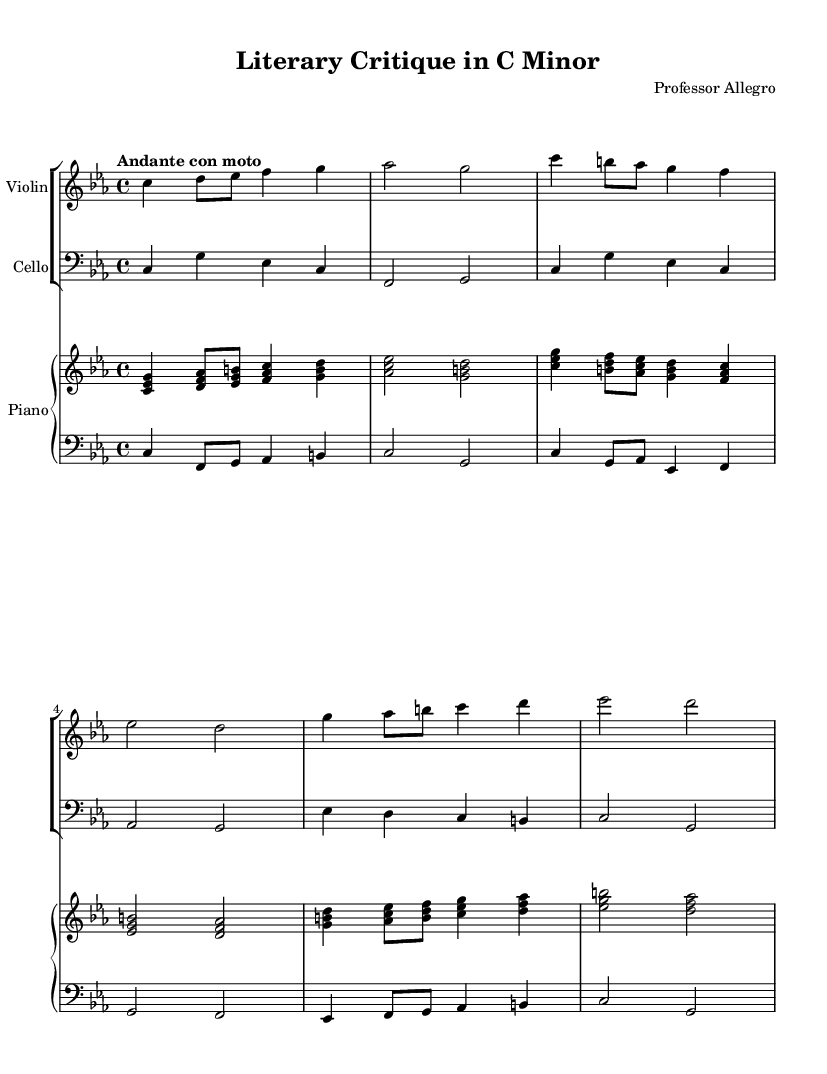What is the key signature of this music? The key signature is indicated at the beginning of the staff; it has three flats (B♭, E♭, and A♭). This is characteristic of C minor.
Answer: C minor What is the time signature of this music? The time signature is displayed at the beginning of the score as a fraction; in this case, it shows 4 over 4, which means there are four beats in each measure, and the quarter note gets one beat.
Answer: 4/4 What is the tempo marking of this composition? The tempo marking is written near the upper part of the score; "Andante con moto" indicates a moderately slow tempo with a bit of movement.
Answer: Andante con moto How many distinct themes are present in this composition? By analyzing the sections labeled as Theme A and Theme B in the score, there are two distinct musical themes within the piece.
Answer: 2 Which instrument plays the bass clef? Looking at the score, the staff labeled "cello" contains the bass clef, which indicates that this instrument plays in the lower range.
Answer: Cello What is the highest pitch played by the piano in the introduction? By examining the notes played in the piano right hand during the introduction, the highest pitch is E♭ in the chord <es g b>.
Answer: E♭ What dynamic marking is used at the beginning of the score? There are no specific dynamic markings placed at the beginning of the score; however, it is common to start with a "p" for piano, indicating softness, even if it's not explicitly written here.
Answer: None 